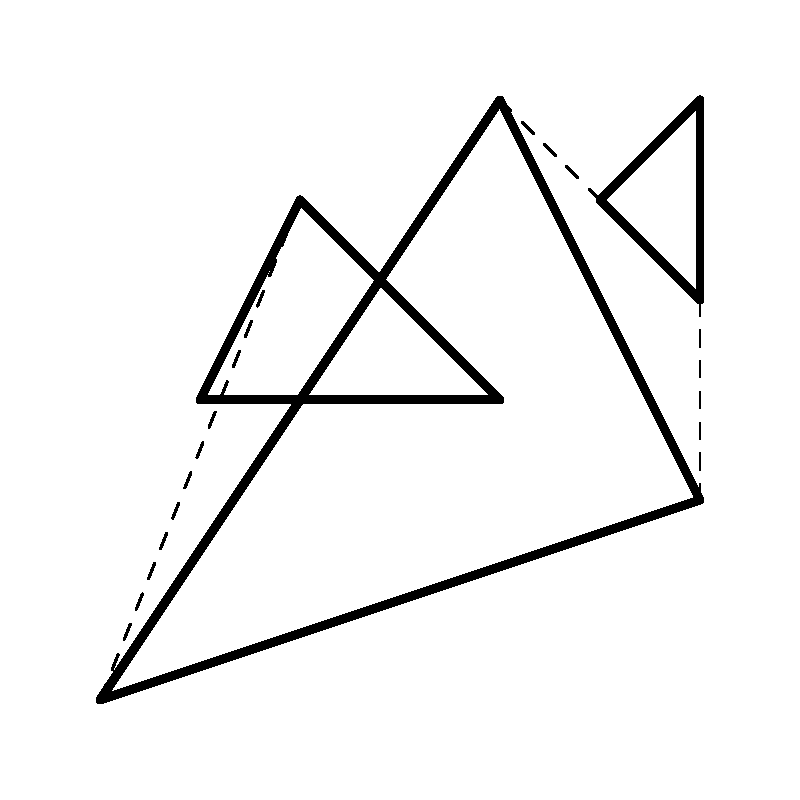In the abstract composition shown above, which technique is primarily used to create a sense of depth and perspective? To answer this question, let's analyze the composition step-by-step:

1. The image consists of three abstract shapes: a large triangle, a smaller triangle, and a small square-like shape.

2. These shapes are connected by dashed lines, which is a key element in creating depth perception.

3. The dashed lines appear to recede into the background, connecting the foreground shapes to background elements.

4. This technique of using converging lines to create depth is known as linear perspective.

5. In abstract art, linear perspective is often simplified and suggested rather than strictly adhered to, as we see in this composition.

6. The varying sizes of the shapes also contribute to the sense of depth, with larger shapes appearing closer and smaller shapes farther away.

7. The overlapping of shapes (the small square-like shape appears to be in front of the large triangle) further enhances the illusion of depth.

However, the primary technique used here to create depth and perspective is the use of dashed lines suggesting linear perspective, albeit in a simplified, abstract manner.
Answer: Simplified linear perspective using dashed lines 